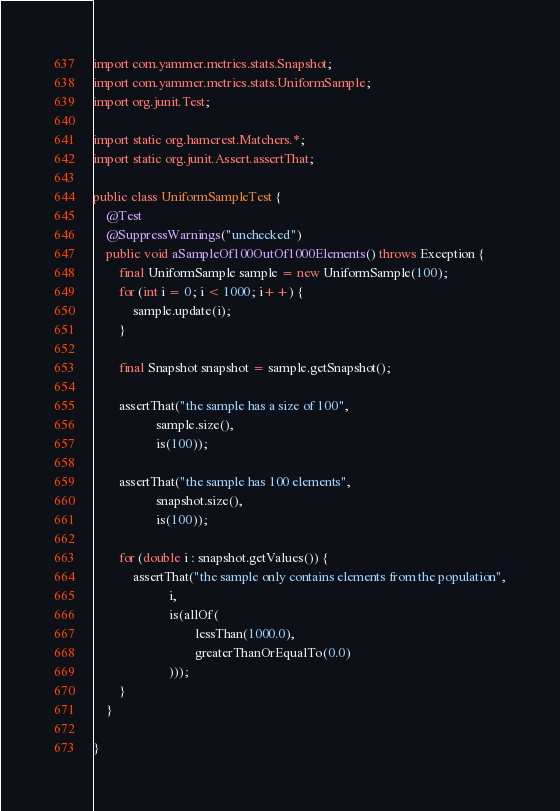<code> <loc_0><loc_0><loc_500><loc_500><_Java_>
import com.yammer.metrics.stats.Snapshot;
import com.yammer.metrics.stats.UniformSample;
import org.junit.Test;

import static org.hamcrest.Matchers.*;
import static org.junit.Assert.assertThat;

public class UniformSampleTest {
    @Test
    @SuppressWarnings("unchecked")
    public void aSampleOf100OutOf1000Elements() throws Exception {
        final UniformSample sample = new UniformSample(100);
        for (int i = 0; i < 1000; i++) {
            sample.update(i);
        }

        final Snapshot snapshot = sample.getSnapshot();

        assertThat("the sample has a size of 100",
                   sample.size(),
                   is(100));

        assertThat("the sample has 100 elements",
                   snapshot.size(),
                   is(100));

        for (double i : snapshot.getValues()) {
            assertThat("the sample only contains elements from the population",
                       i,
                       is(allOf(
                               lessThan(1000.0),
                               greaterThanOrEqualTo(0.0)
                       )));
        }
    }

}
</code> 